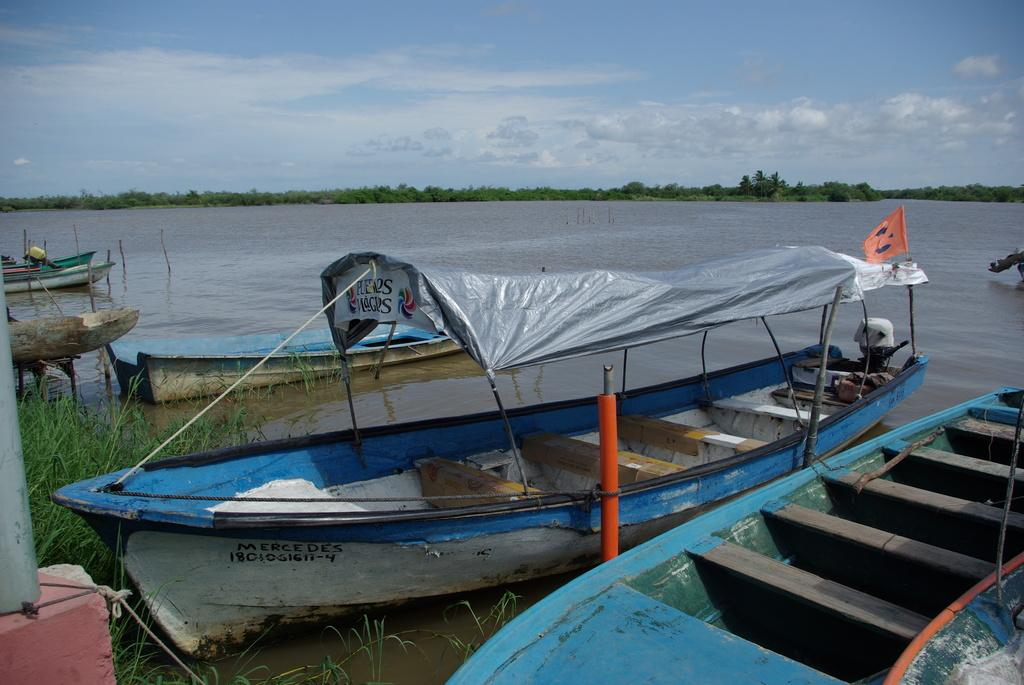What is floating on the surface of the water in the image? There are boats on the surface of the water in the image. What can be seen flying or waving in the image? There is a flag visible in the image. What type of vegetation is present in the image? Trees and grass are visible in the image. What objects are used for tying or securing in the image? Ropes are present in the image. What objects are used for supporting or holding in the image? Rods are present in the image. What part of the natural environment is visible in the image? The sky is visible in the image. What can be seen in the sky in the image? Clouds are visible in the sky. How many crows are sitting on the boats in the image? There are no crows present in the image; it features boats on the water with a flag, trees, grass, ropes, rods, and a sky with clouds. What type of furniture is visible in the image? There is no furniture present in the image, as it primarily features boats, water, a flag, trees, grass, ropes, rods, and a sky with clouds. 